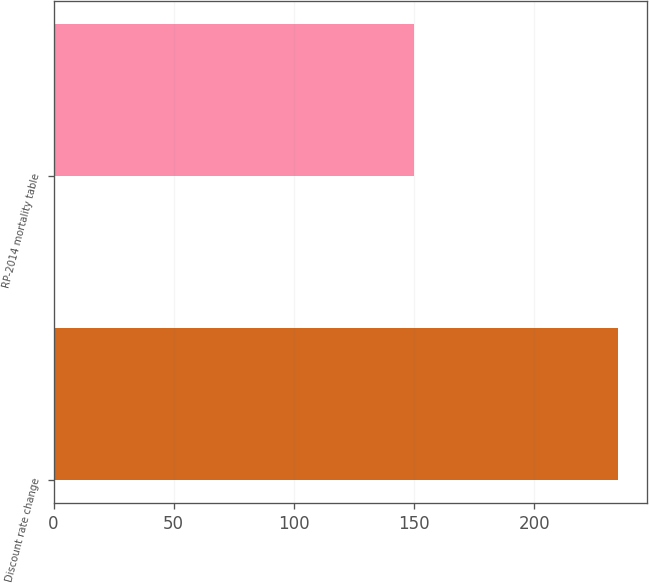Convert chart. <chart><loc_0><loc_0><loc_500><loc_500><bar_chart><fcel>Discount rate change<fcel>RP-2014 mortality table<nl><fcel>235<fcel>150<nl></chart> 